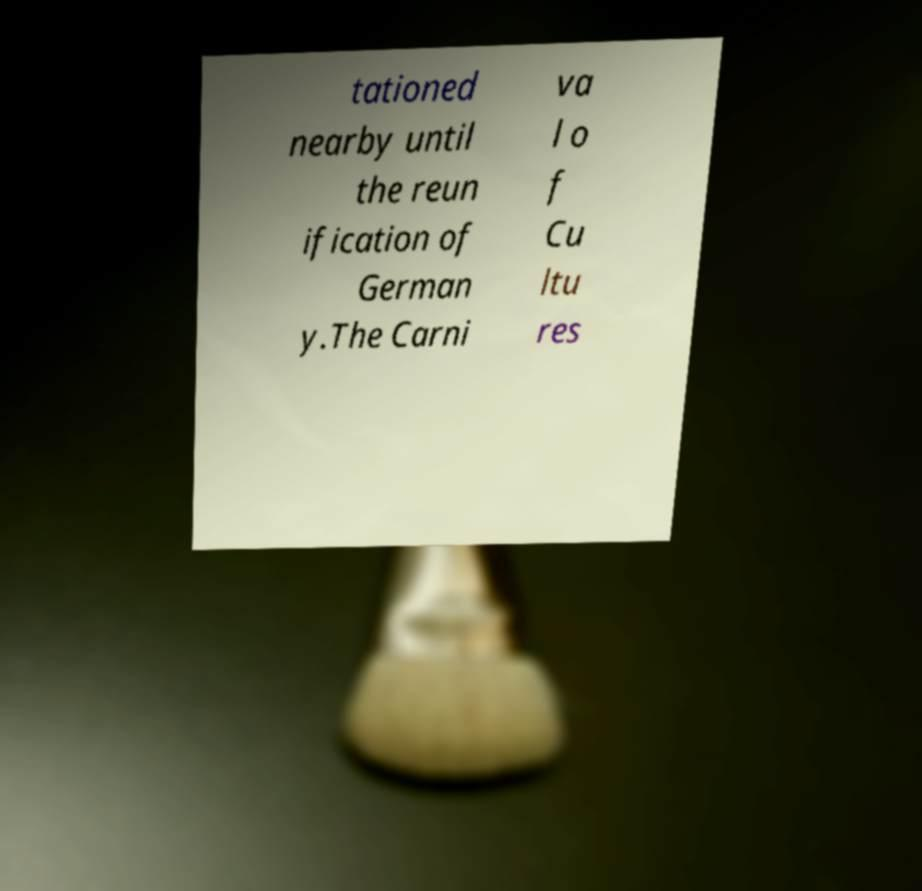For documentation purposes, I need the text within this image transcribed. Could you provide that? tationed nearby until the reun ification of German y.The Carni va l o f Cu ltu res 